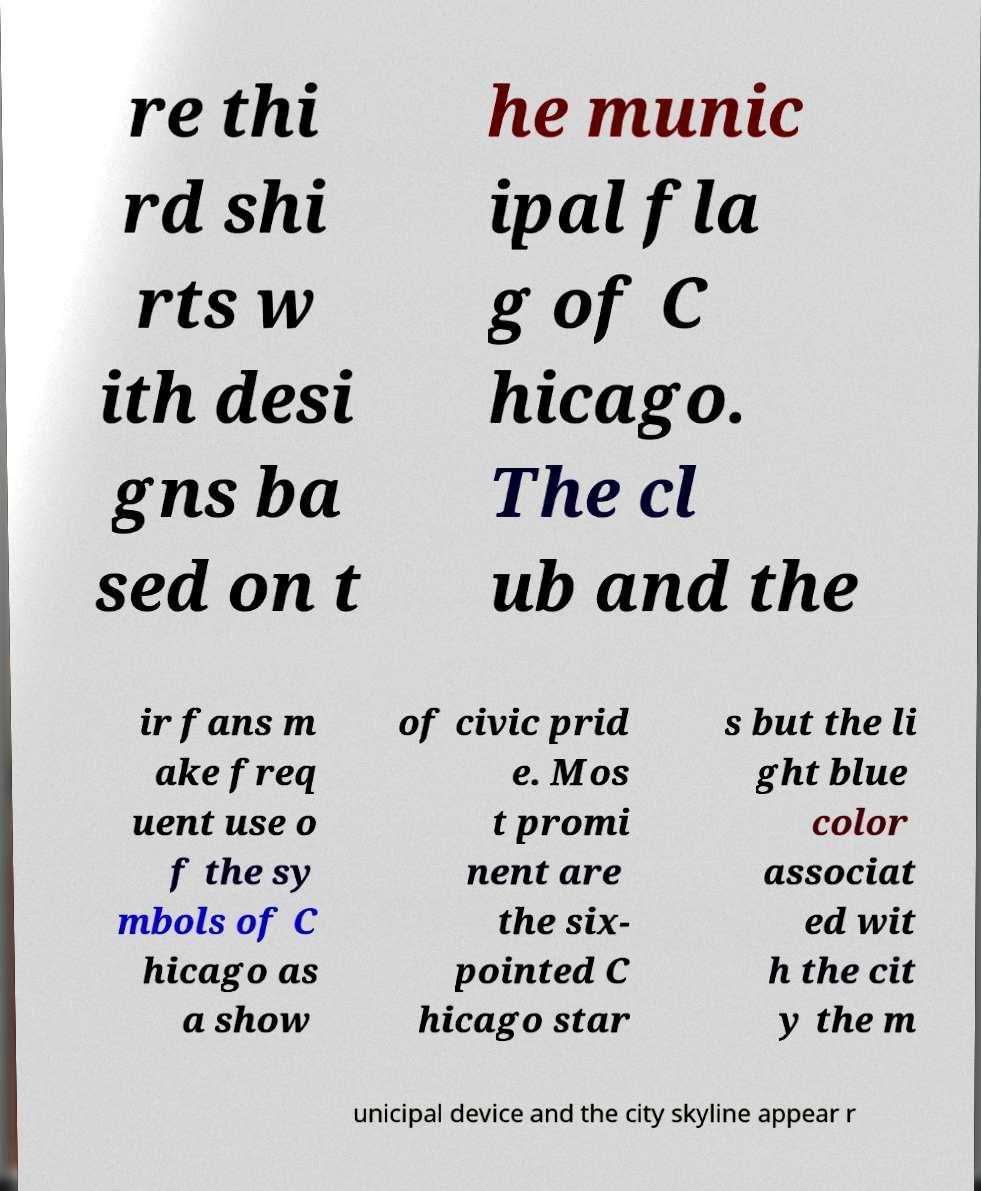For documentation purposes, I need the text within this image transcribed. Could you provide that? re thi rd shi rts w ith desi gns ba sed on t he munic ipal fla g of C hicago. The cl ub and the ir fans m ake freq uent use o f the sy mbols of C hicago as a show of civic prid e. Mos t promi nent are the six- pointed C hicago star s but the li ght blue color associat ed wit h the cit y the m unicipal device and the city skyline appear r 